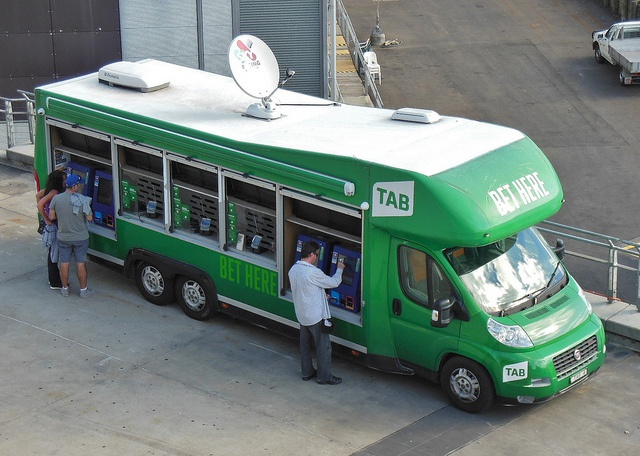Describe the objects in this image and their specific colors. I can see bus in black, white, and darkgreen tones, people in black and darkgray tones, people in black, gray, darkblue, and navy tones, truck in black, darkgray, and gray tones, and people in black, gray, and brown tones in this image. 